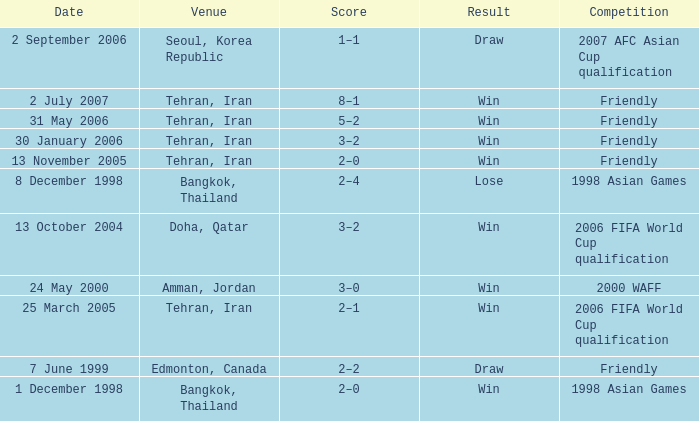Could you help me parse every detail presented in this table? {'header': ['Date', 'Venue', 'Score', 'Result', 'Competition'], 'rows': [['2 September 2006', 'Seoul, Korea Republic', '1–1', 'Draw', '2007 AFC Asian Cup qualification'], ['2 July 2007', 'Tehran, Iran', '8–1', 'Win', 'Friendly'], ['31 May 2006', 'Tehran, Iran', '5–2', 'Win', 'Friendly'], ['30 January 2006', 'Tehran, Iran', '3–2', 'Win', 'Friendly'], ['13 November 2005', 'Tehran, Iran', '2–0', 'Win', 'Friendly'], ['8 December 1998', 'Bangkok, Thailand', '2–4', 'Lose', '1998 Asian Games'], ['13 October 2004', 'Doha, Qatar', '3–2', 'Win', '2006 FIFA World Cup qualification'], ['24 May 2000', 'Amman, Jordan', '3–0', 'Win', '2000 WAFF'], ['25 March 2005', 'Tehran, Iran', '2–1', 'Win', '2006 FIFA World Cup qualification'], ['7 June 1999', 'Edmonton, Canada', '2–2', 'Draw', 'Friendly'], ['1 December 1998', 'Bangkok, Thailand', '2–0', 'Win', '1998 Asian Games']]} What was the competition on 7 June 1999? Friendly. 